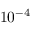Convert formula to latex. <formula><loc_0><loc_0><loc_500><loc_500>1 0 ^ { - 4 }</formula> 